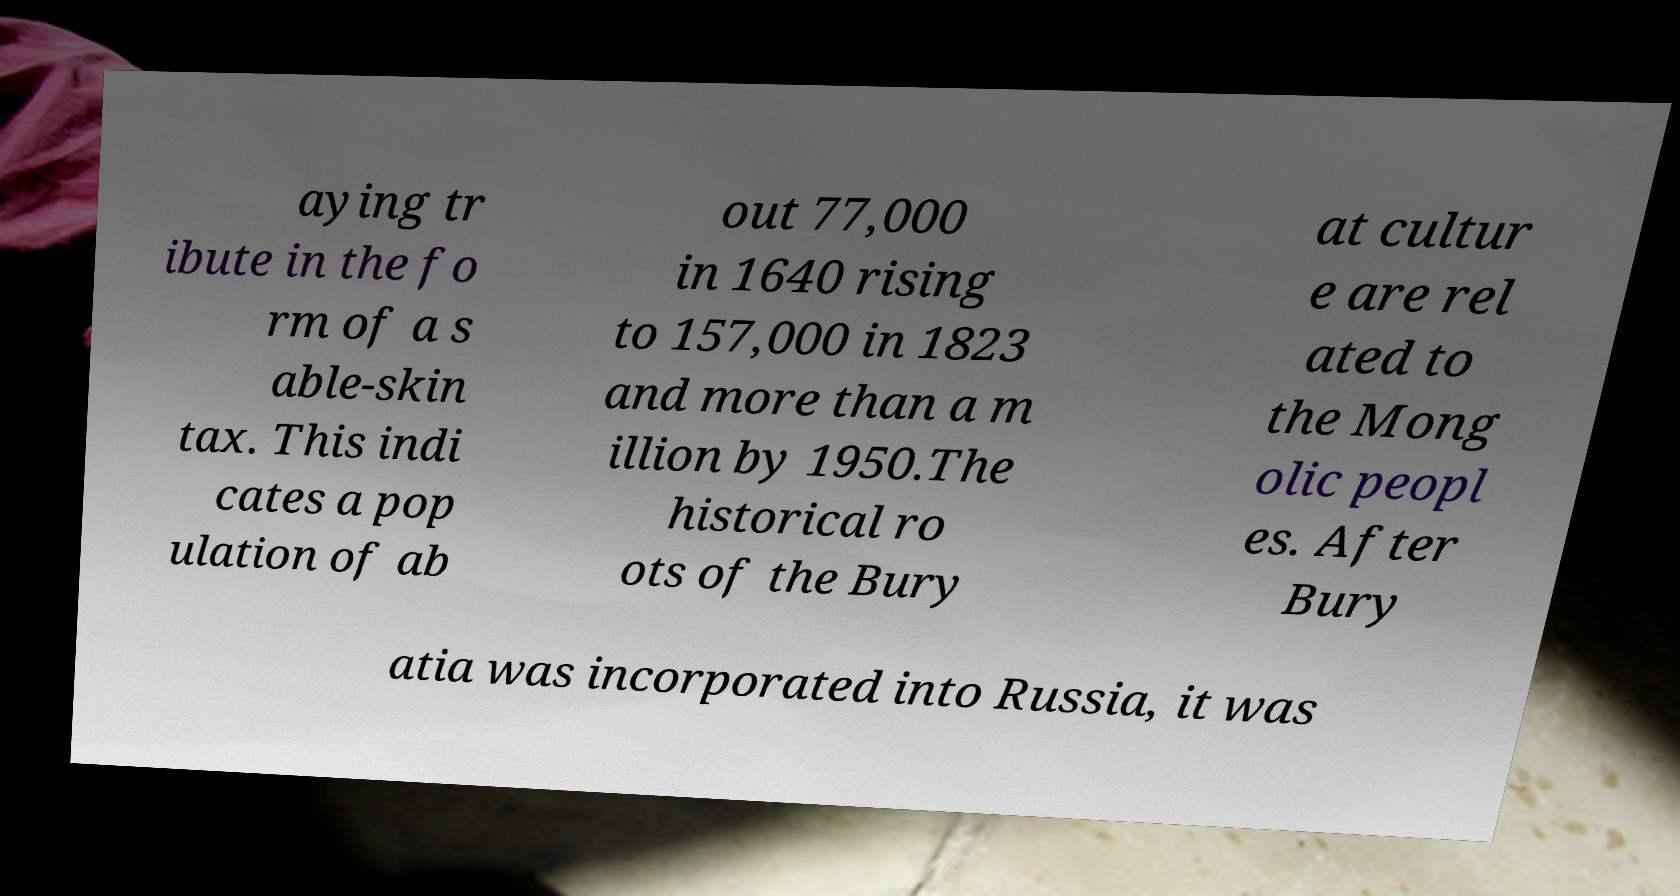Can you accurately transcribe the text from the provided image for me? aying tr ibute in the fo rm of a s able-skin tax. This indi cates a pop ulation of ab out 77,000 in 1640 rising to 157,000 in 1823 and more than a m illion by 1950.The historical ro ots of the Bury at cultur e are rel ated to the Mong olic peopl es. After Bury atia was incorporated into Russia, it was 